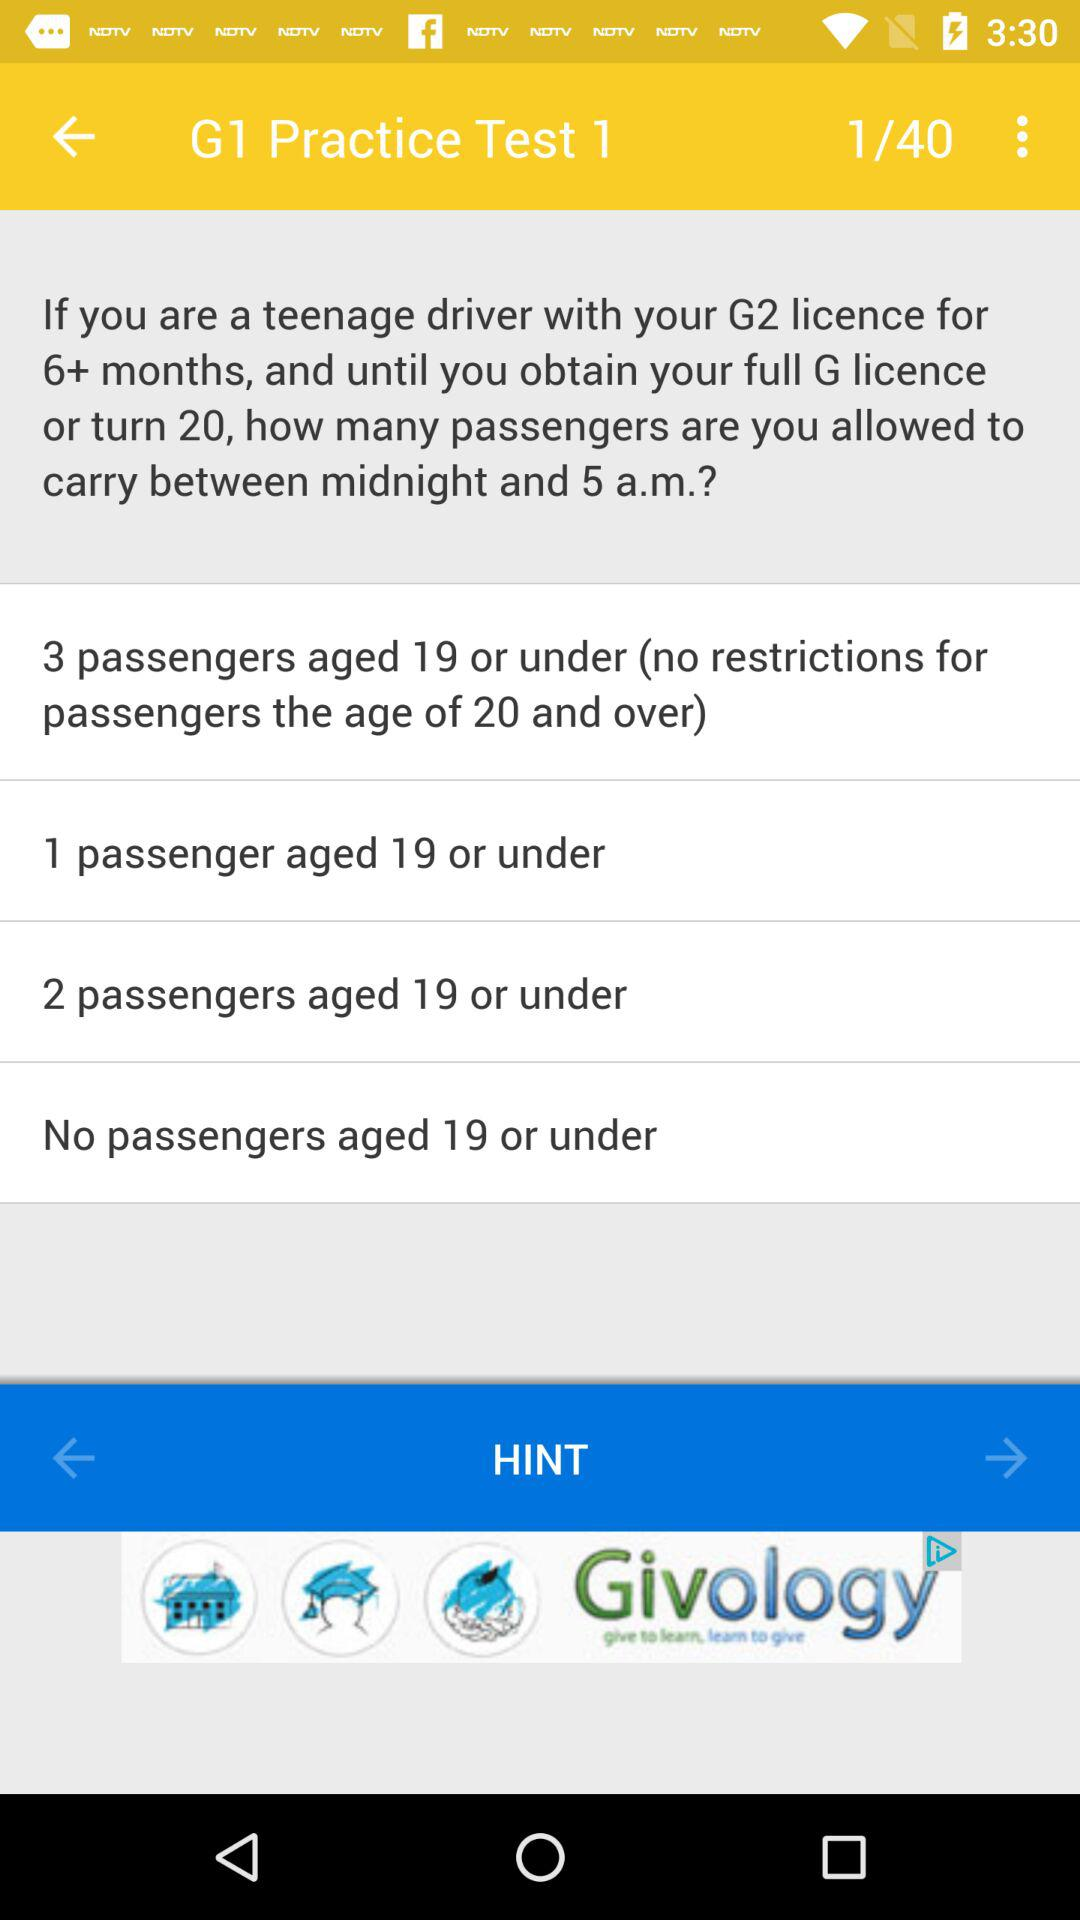What age of passengers has no restrictions? There are no age restrictions for those who are 19 and under. 